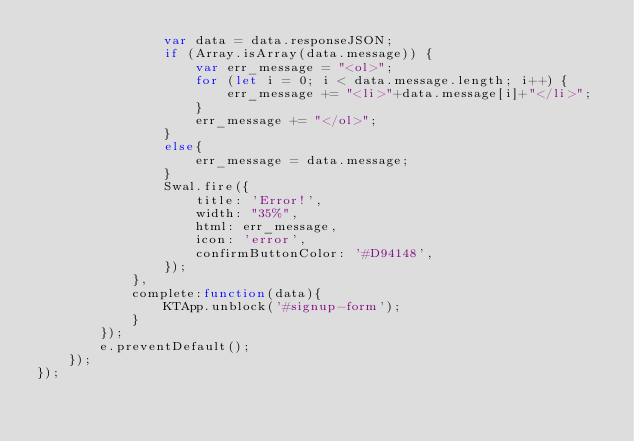Convert code to text. <code><loc_0><loc_0><loc_500><loc_500><_JavaScript_>                var data = data.responseJSON;
                if (Array.isArray(data.message)) {
                    var err_message = "<ol>";
                    for (let i = 0; i < data.message.length; i++) {
                        err_message += "<li>"+data.message[i]+"</li>";
                    }
                    err_message += "</ol>";
                }
                else{
                    err_message = data.message;
                }
                Swal.fire({
                    title: 'Error!',
                    width: "35%",
                    html: err_message,
                    icon: 'error',
                    confirmButtonColor: '#D94148',
                });
            },
            complete:function(data){
                KTApp.unblock('#signup-form');
            }
        });
        e.preventDefault();
    });
});</code> 